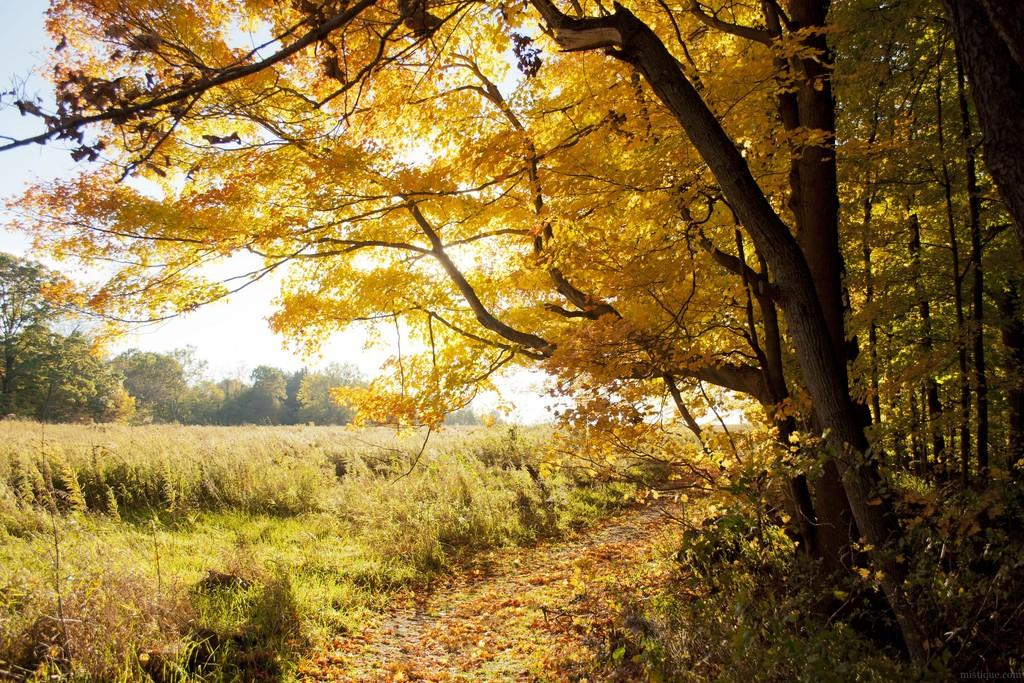What type of vegetation is visible in the front of the image? There are trees in the front of the image. What type of vegetation is visible in the background of the image? There are trees in the background of the image. What type of ground cover is present in the center of the image? There is grass in the center of the image. Where is the tub located in the image? There is no tub present in the image. What type of twig can be seen in the prose of the image? There is no prose present in the image, and therefore no twigs can be seen in it. 